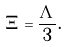Convert formula to latex. <formula><loc_0><loc_0><loc_500><loc_500>\Xi = \frac { \Lambda } { 3 } .</formula> 